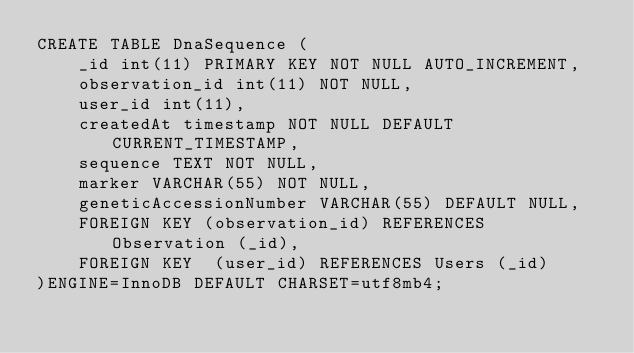Convert code to text. <code><loc_0><loc_0><loc_500><loc_500><_SQL_>CREATE TABLE DnaSequence (
	_id int(11) PRIMARY KEY NOT NULL AUTO_INCREMENT,
	observation_id int(11) NOT NULL,
	user_id int(11),
	createdAt timestamp NOT NULL DEFAULT CURRENT_TIMESTAMP,
	sequence TEXT NOT NULL,
	marker VARCHAR(55) NOT NULL,
	geneticAccessionNumber VARCHAR(55) DEFAULT NULL,
	FOREIGN KEY (observation_id) REFERENCES Observation (_id),
	FOREIGN KEY  (user_id) REFERENCES Users (_id)	
)ENGINE=InnoDB DEFAULT CHARSET=utf8mb4;</code> 